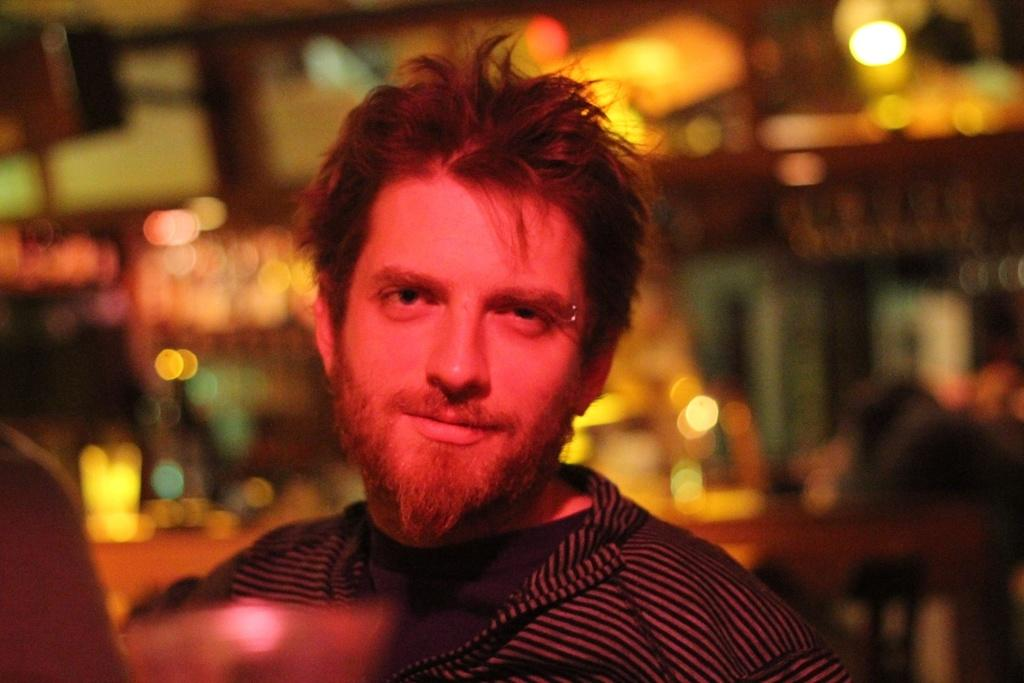Who is present in the image? There is a man in the image. What can be seen in the background of the image? There are lights visible in the background of the image. What type of ornament is the man reading in the image? There is no ornament present in the image, nor is the man reading anything. 